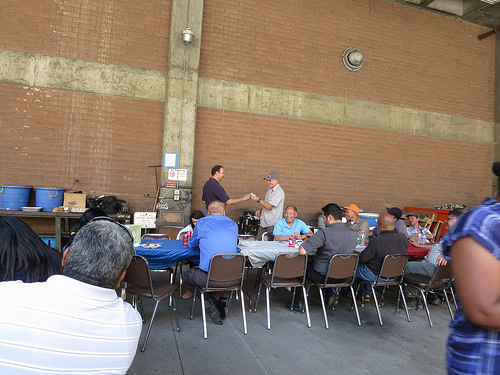<image>
Can you confirm if the man is on the chair? No. The man is not positioned on the chair. They may be near each other, but the man is not supported by or resting on top of the chair. 